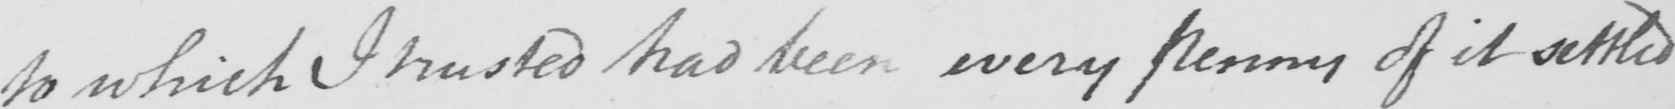What does this handwritten line say? to which I trusted had been every penny of it settled 